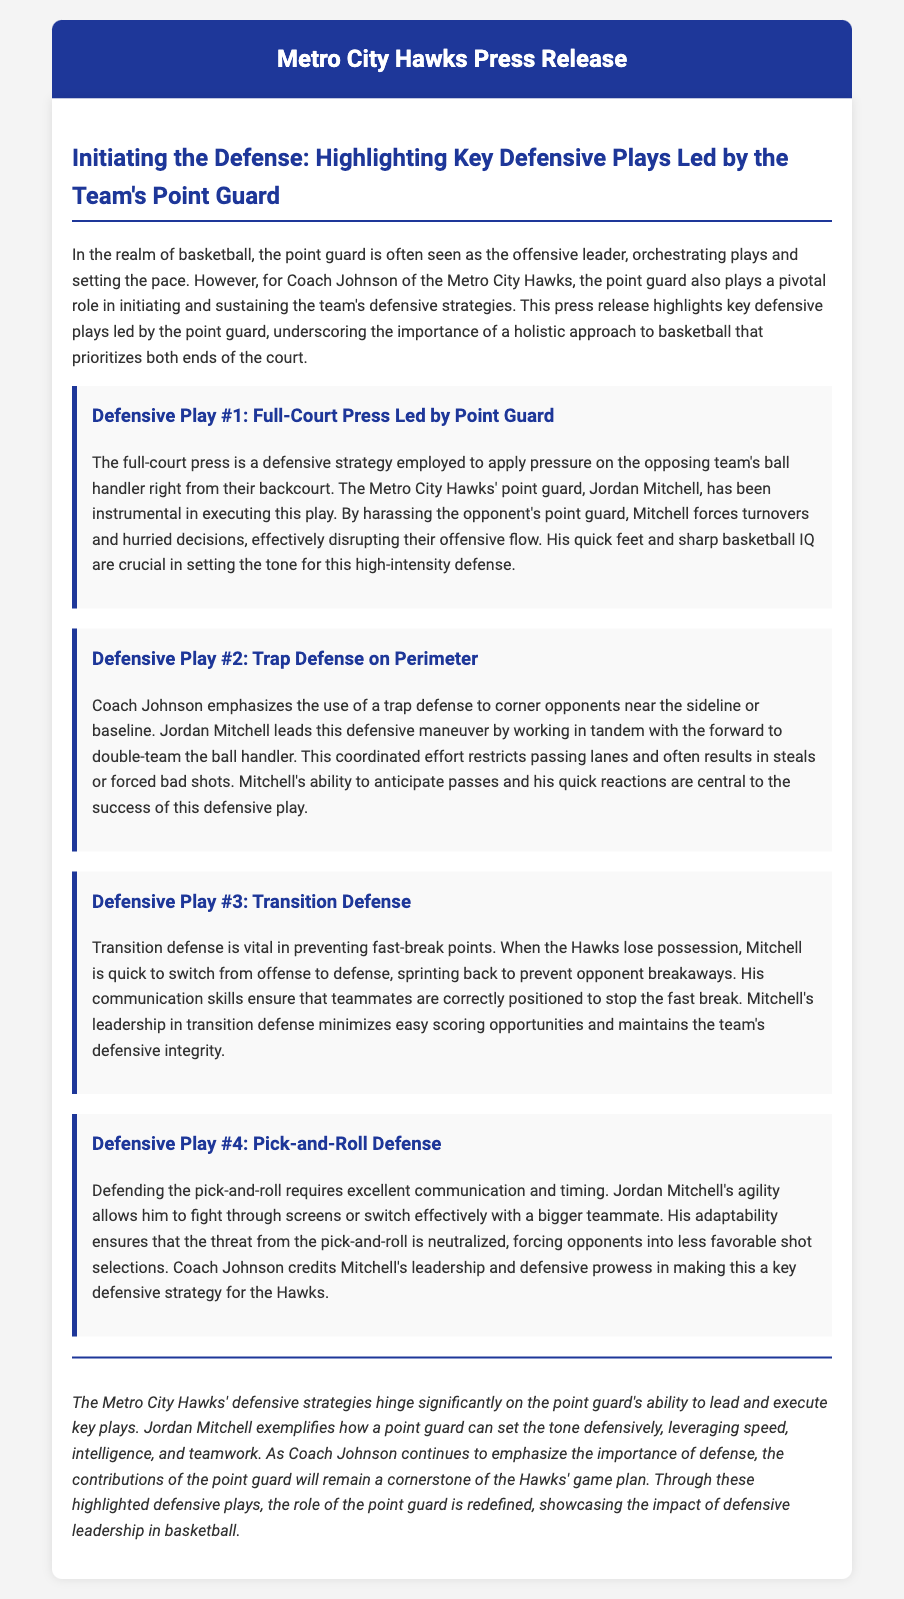what is the name of the point guard highlighted in the press release? The document specifies that the point guard's name is Jordan Mitchell.
Answer: Jordan Mitchell how does Jordan Mitchell apply pressure on the opposing team's ball handler? The press release states that Mitchell applies pressure through a full-court press to force turnovers and hurried decisions.
Answer: Full-court press what defensive play does Coach Johnson emphasize to restrict passing lanes? The document mentions that a trap defense is emphasized to corner opponents and restrict passing lanes.
Answer: Trap defense which defensive play is crucial in preventing fast-break points? According to the document, transition defense is vital to prevent fast-break points when the Hawks lose possession.
Answer: Transition defense how does Jordan Mitchell adapt during the pick-and-roll defense? The press release describes that Mitchell shows adaptability by fighting through screens or switching effectively with a teammate during pick-and-roll defense.
Answer: Adaptability what is the overall tone of the press release regarding the defense and point guard's role? The document conveys a positive tone, emphasizing how Jordan Mitchell exemplifies a point guard's significance in defensive strategies.
Answer: Positive what does Coach Johnson credit Jordan Mitchell for in the context of pick-and-roll defense? The document indicates that Coach Johnson credits Mitchell's leadership and defensive prowess in making pick-and-roll defense a key strategy.
Answer: Leadership and defensive prowess what is the conclusion's focus regarding the point guard's role? The conclusion emphasizes that the point guard's ability to lead and execute key plays significantly influences the Hawks' defensive strategies.
Answer: Leading and executing key plays 